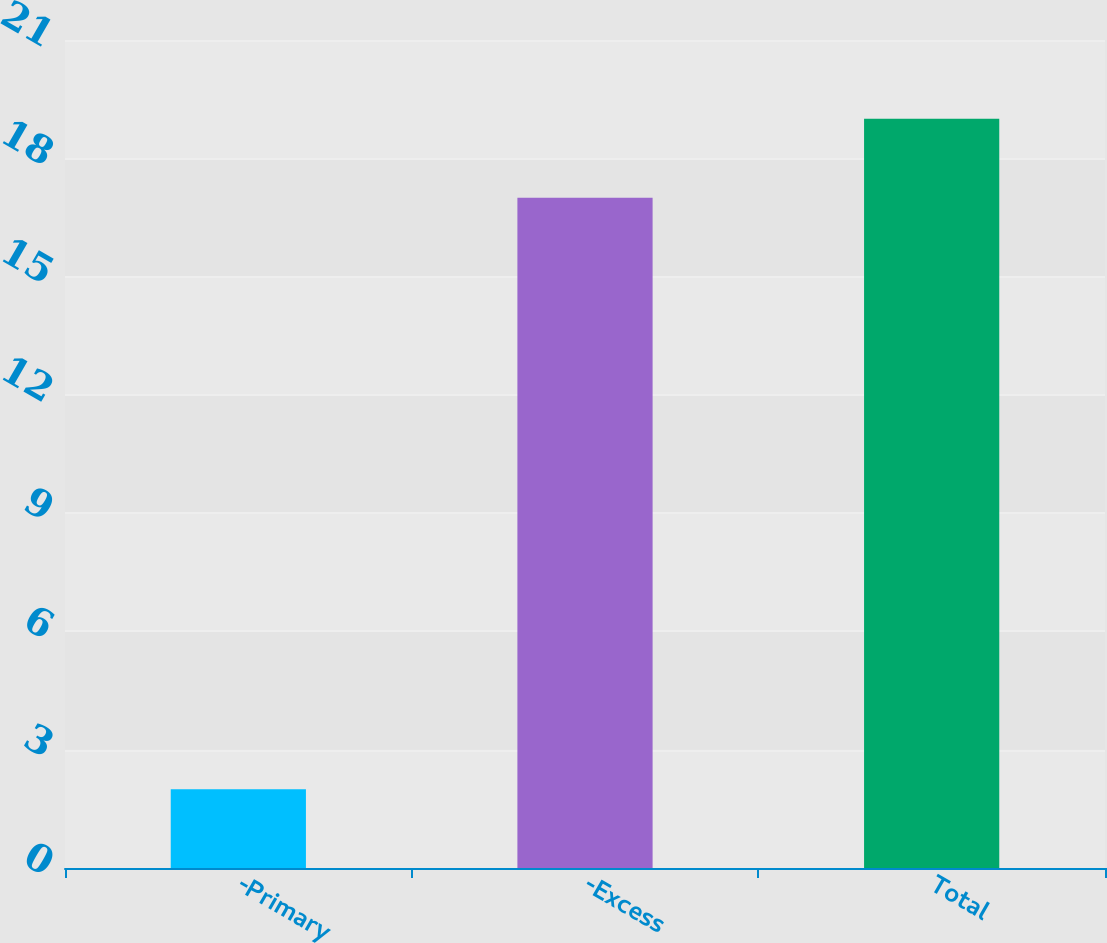<chart> <loc_0><loc_0><loc_500><loc_500><bar_chart><fcel>-Primary<fcel>-Excess<fcel>Total<nl><fcel>2<fcel>17<fcel>19<nl></chart> 